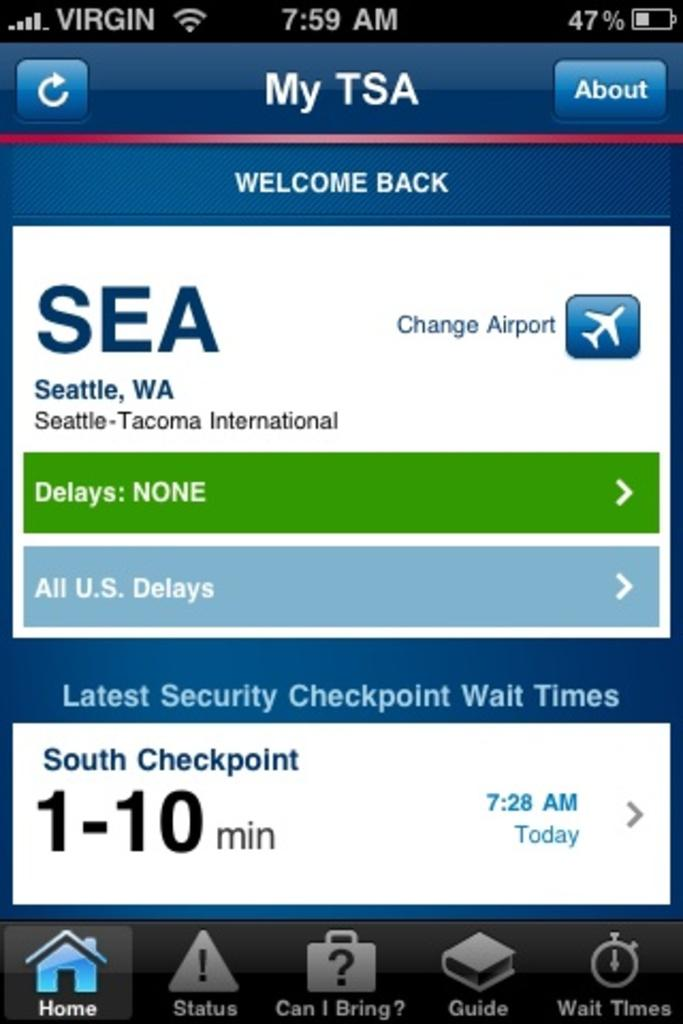Provide a one-sentence caption for the provided image. TSA screen for an application displays the South Checkpoint as a 1-10 min wait time. 